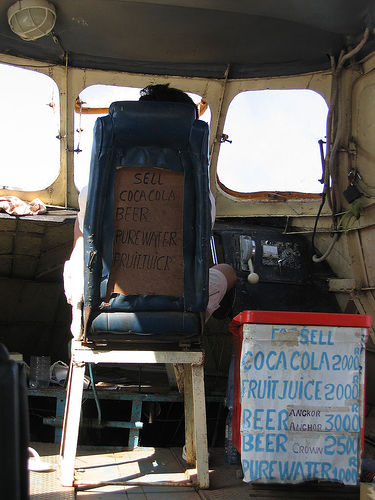<image>
Is the man in front of the sign? No. The man is not in front of the sign. The spatial positioning shows a different relationship between these objects. 